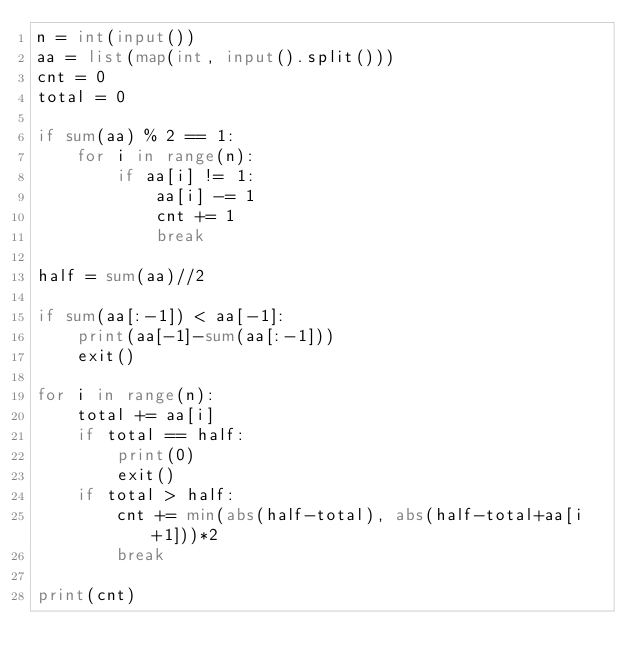<code> <loc_0><loc_0><loc_500><loc_500><_Python_>n = int(input())
aa = list(map(int, input().split()))
cnt = 0
total = 0

if sum(aa) % 2 == 1:
    for i in range(n):
        if aa[i] != 1:
            aa[i] -= 1
            cnt += 1
            break

half = sum(aa)//2

if sum(aa[:-1]) < aa[-1]:
    print(aa[-1]-sum(aa[:-1]))
    exit()

for i in range(n):
    total += aa[i]
    if total == half:
        print(0)
        exit()
    if total > half:
        cnt += min(abs(half-total), abs(half-total+aa[i+1]))*2
        break

print(cnt)
</code> 